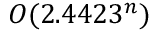Convert formula to latex. <formula><loc_0><loc_0><loc_500><loc_500>O ( 2 . 4 4 2 3 ^ { n } )</formula> 